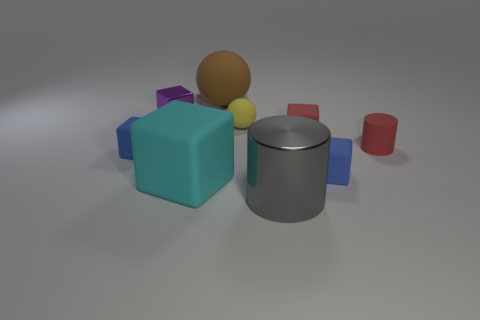Is there anything else that has the same size as the brown rubber object?
Ensure brevity in your answer.  Yes. There is a small cube that is the same color as the small matte cylinder; what is it made of?
Make the answer very short. Rubber. What size is the rubber block in front of the blue rubber cube that is to the right of the tiny purple metallic cube?
Your answer should be very brief. Large. Are there any tiny cylinders that have the same material as the yellow sphere?
Ensure brevity in your answer.  Yes. What material is the red cube that is the same size as the purple metal object?
Your response must be concise. Rubber. There is a metal object that is on the left side of the large brown ball; does it have the same color as the matte object that is left of the cyan thing?
Give a very brief answer. No. There is a big thing that is left of the large brown matte ball; is there a matte cube that is on the right side of it?
Give a very brief answer. Yes. Does the metal object behind the large gray object have the same shape as the large rubber object that is in front of the large ball?
Make the answer very short. Yes. Does the large object that is to the right of the big brown matte sphere have the same material as the small blue thing that is on the left side of the cyan rubber thing?
Give a very brief answer. No. What material is the red block that is right of the sphere that is in front of the big brown matte ball?
Offer a very short reply. Rubber. 